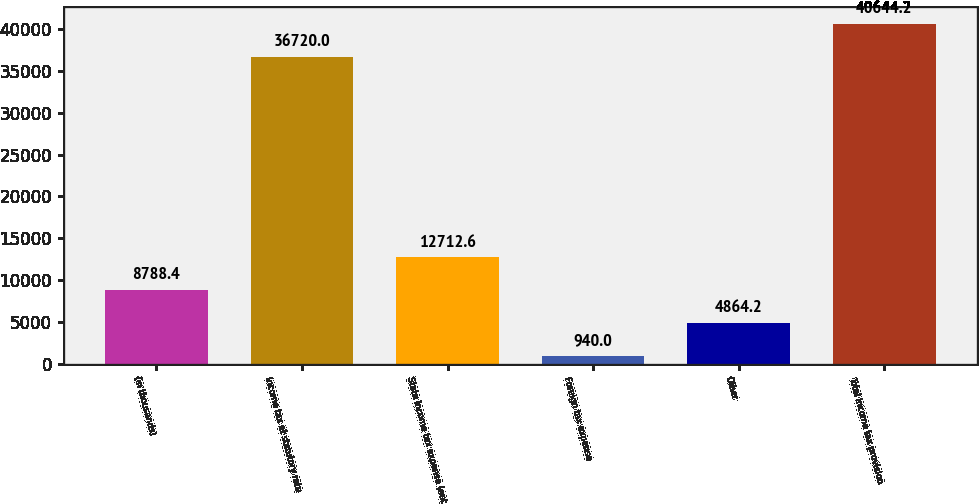Convert chart. <chart><loc_0><loc_0><loc_500><loc_500><bar_chart><fcel>(in thousands)<fcel>Income tax at statutory rate<fcel>State income tax expense (net<fcel>Foreign tax expense<fcel>Other<fcel>Total income tax provision<nl><fcel>8788.4<fcel>36720<fcel>12712.6<fcel>940<fcel>4864.2<fcel>40644.2<nl></chart> 